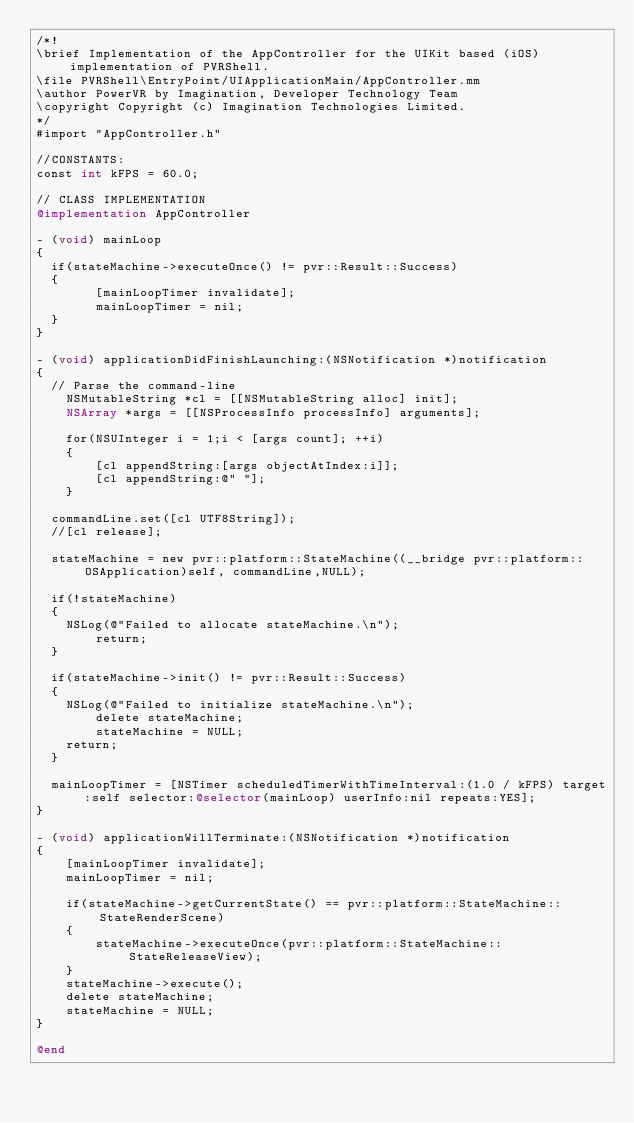<code> <loc_0><loc_0><loc_500><loc_500><_ObjectiveC_>/*!
\brief Implementation of the AppController for the UIKit based (iOS) implementation of PVRShell.
\file PVRShell\EntryPoint/UIApplicationMain/AppController.mm
\author PowerVR by Imagination, Developer Technology Team
\copyright Copyright (c) Imagination Technologies Limited.
*/
#import "AppController.h"

//CONSTANTS:
const int kFPS = 60.0;

// CLASS IMPLEMENTATION
@implementation AppController

- (void) mainLoop
{
	if(stateMachine->executeOnce() != pvr::Result::Success)
	{		
        [mainLoopTimer invalidate];
        mainLoopTimer = nil;
	}
}

- (void) applicationDidFinishLaunching:(NSNotification *)notification
{
	// Parse the command-line
    NSMutableString *cl = [[NSMutableString alloc] init];
    NSArray *args = [[NSProcessInfo processInfo] arguments];
    
    for(NSUInteger i = 1;i < [args count]; ++i)
    {
        [cl appendString:[args objectAtIndex:i]];
        [cl appendString:@" "];
    }
	
	commandLine.set([cl UTF8String]);
	//[cl release];
	
	stateMachine = new pvr::platform::StateMachine((__bridge pvr::platform::OSApplication)self, commandLine,NULL);

	if(!stateMachine)
	{
		NSLog(@"Failed to allocate stateMachine.\n");
        return;
	}
	
	if(stateMachine->init() != pvr::Result::Success)
	{
		NSLog(@"Failed to initialize stateMachine.\n");
        delete stateMachine;
        stateMachine = NULL;
		return;
	}
	
	mainLoopTimer = [NSTimer scheduledTimerWithTimeInterval:(1.0 / kFPS) target:self selector:@selector(mainLoop) userInfo:nil repeats:YES];	
}

- (void) applicationWillTerminate:(NSNotification *)notification
{
    [mainLoopTimer invalidate];
    mainLoopTimer = nil;
    
    if(stateMachine->getCurrentState() == pvr::platform::StateMachine::StateRenderScene)
    {
        stateMachine->executeOnce(pvr::platform::StateMachine::StateReleaseView);
    }
    stateMachine->execute();
    delete stateMachine;
    stateMachine = NULL;
}

@end
</code> 